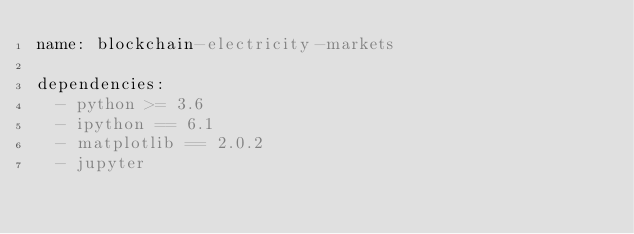<code> <loc_0><loc_0><loc_500><loc_500><_YAML_>name: blockchain-electricity-markets

dependencies:
  - python >= 3.6
  - ipython == 6.1
  - matplotlib == 2.0.2
  - jupyter
</code> 